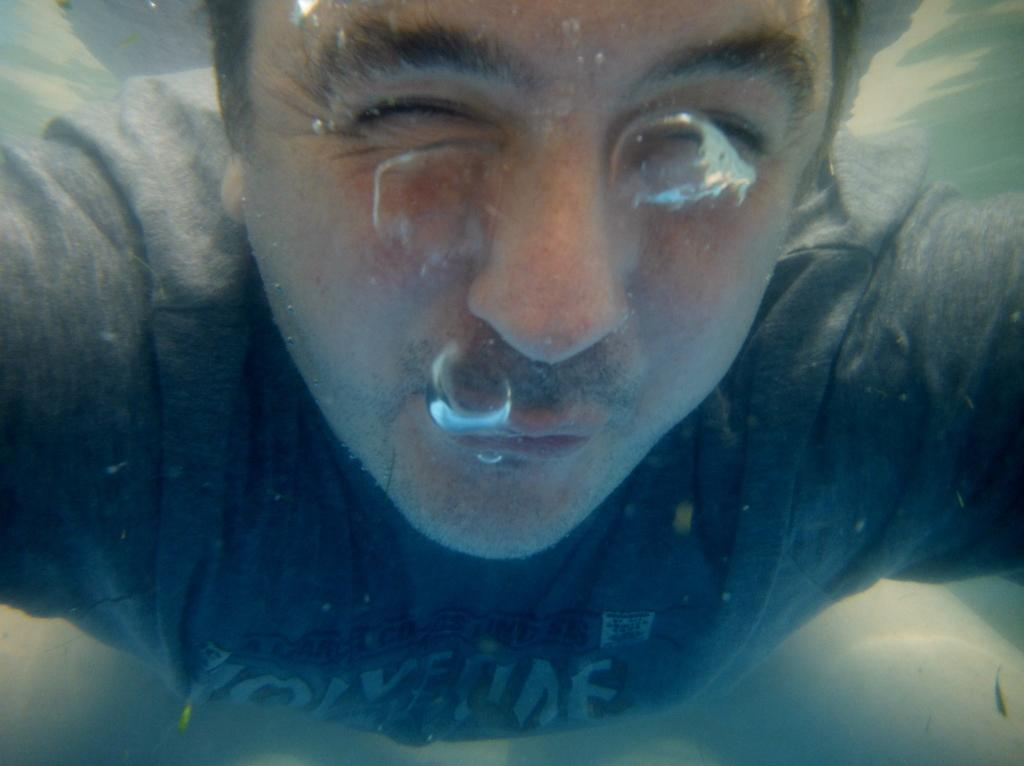Who or what is present in the image? There is a person in the image. Can you describe the setting or environment in which the person is located? The person is in water. How many spiders are crawling on the person's suit in the image? There is no suit or spiders present in the image; the person is in water. 